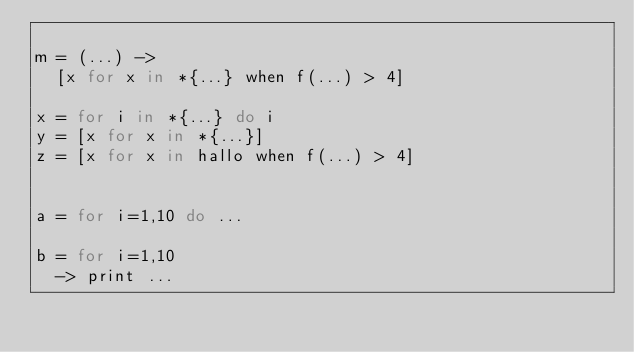Convert code to text. <code><loc_0><loc_0><loc_500><loc_500><_MoonScript_>
m = (...) ->
  [x for x in *{...} when f(...) > 4]

x = for i in *{...} do i
y = [x for x in *{...}]
z = [x for x in hallo when f(...) > 4]


a = for i=1,10 do ...

b = for i=1,10
  -> print ...


</code> 